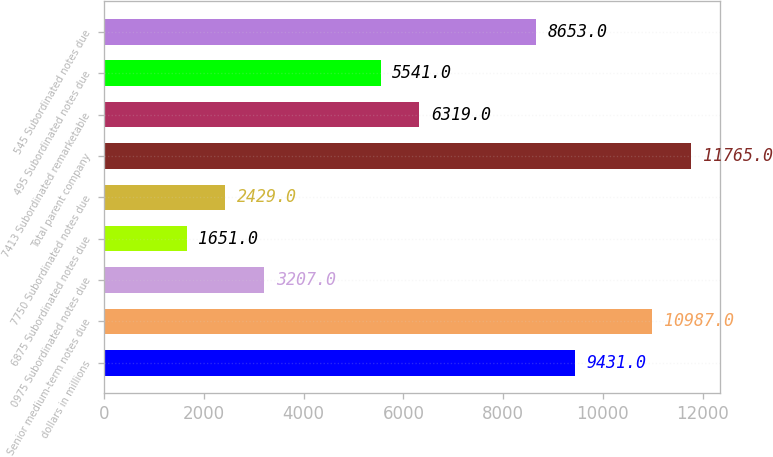<chart> <loc_0><loc_0><loc_500><loc_500><bar_chart><fcel>dollars in millions<fcel>Senior medium-term notes due<fcel>0975 Subordinated notes due<fcel>6875 Subordinated notes due<fcel>7750 Subordinated notes due<fcel>Total parent company<fcel>7413 Subordinated remarketable<fcel>495 Subordinated notes due<fcel>545 Subordinated notes due<nl><fcel>9431<fcel>10987<fcel>3207<fcel>1651<fcel>2429<fcel>11765<fcel>6319<fcel>5541<fcel>8653<nl></chart> 